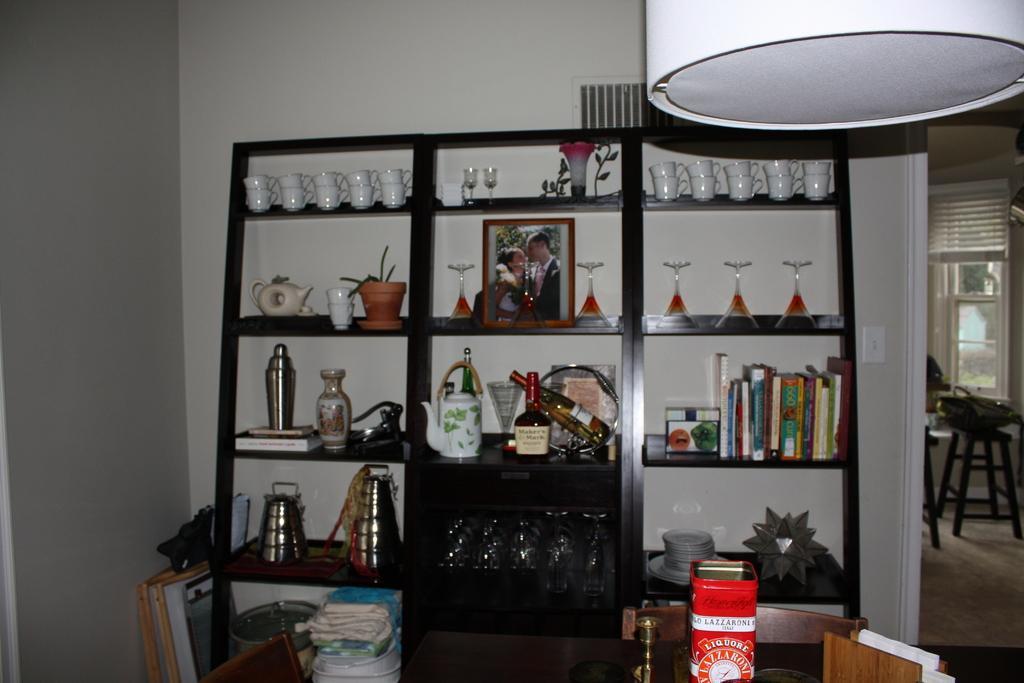How would you summarize this image in a sentence or two? In this picture I can see the objects on the racks. I can see sitting chairs and tables. I can see the glass window on the right side. 